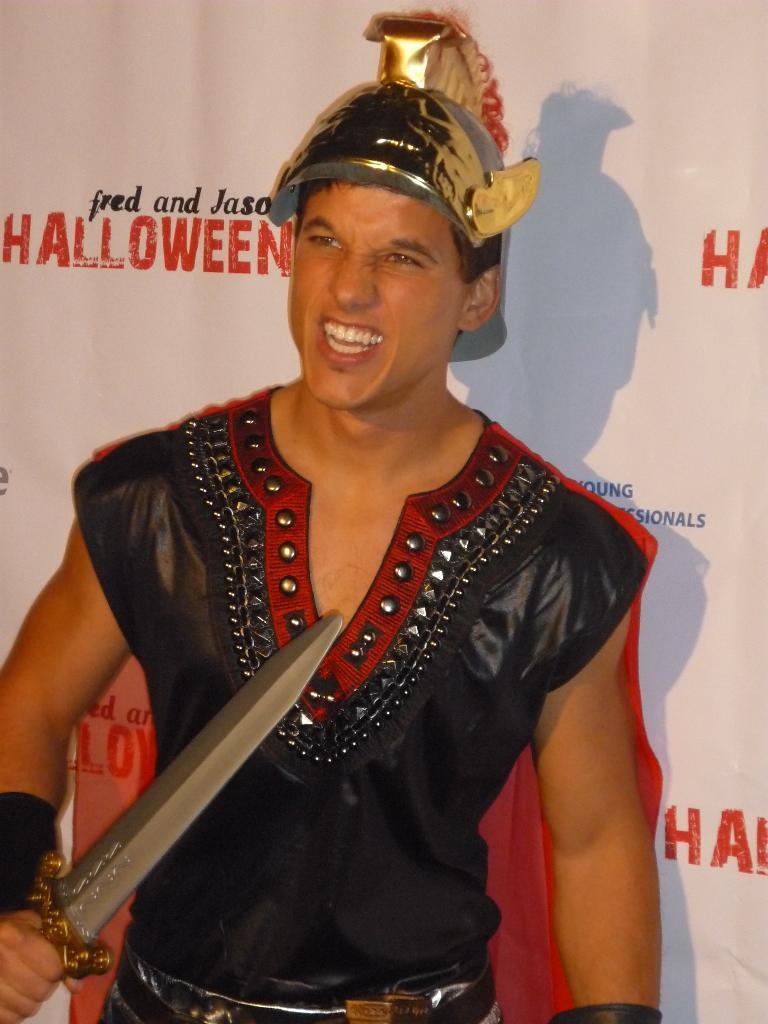Please provide a concise description of this image. In this picture we can see a man in the fancy dress and the man is holding a sword. Behind the man there is a banner and a shadow. 